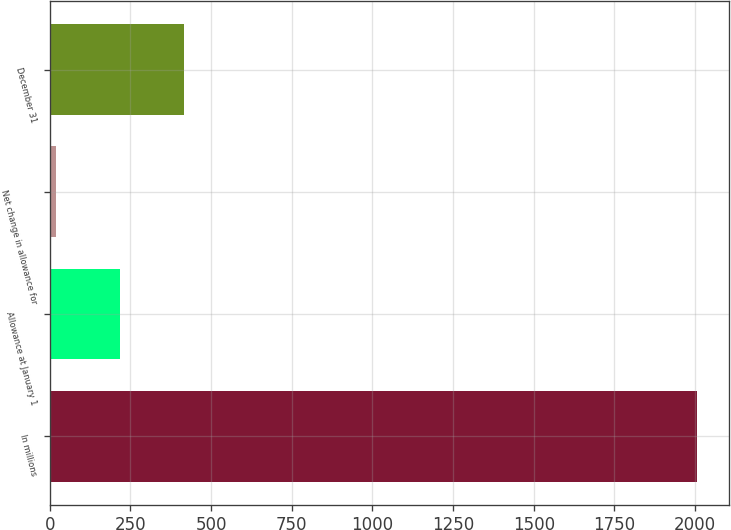Convert chart to OTSL. <chart><loc_0><loc_0><loc_500><loc_500><bar_chart><fcel>In millions<fcel>Allowance at January 1<fcel>Net change in allowance for<fcel>December 31<nl><fcel>2006<fcel>218.6<fcel>20<fcel>417.2<nl></chart> 